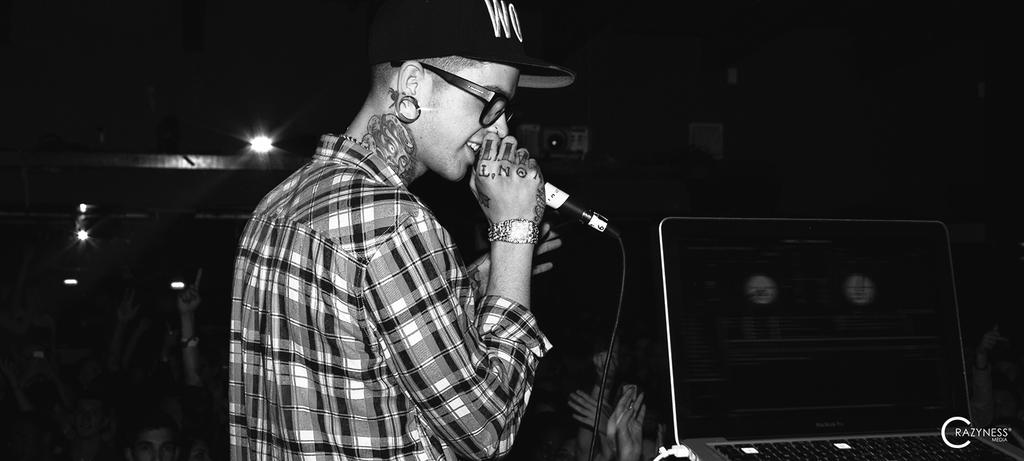What is the person in the image holding? The person is holding a microphone in the image. Can you describe the person's appearance? The person is wearing spectacles and a black color cap. What can be seen on the right side of the image? There are lights visible on the right side of the image. What type of muscle can be seen flexing in the image? There is no muscle visible in the image; it features a person holding a microphone. Can you describe the cave in the image? There is no cave present in the image. 